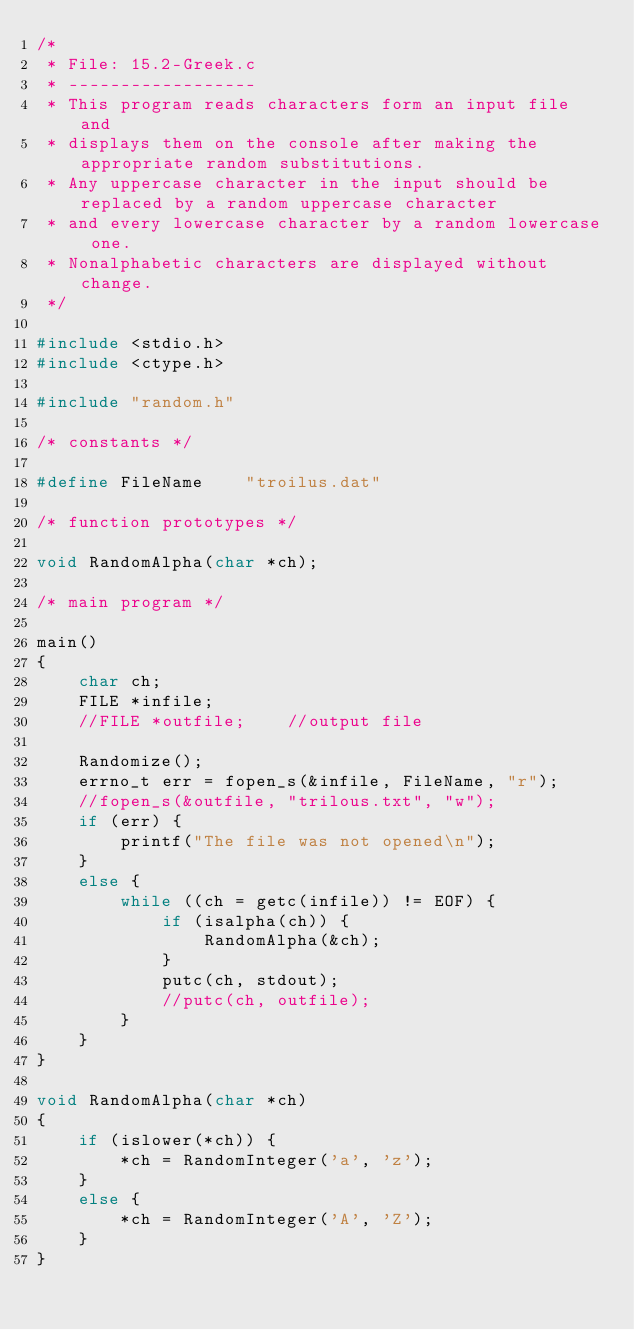<code> <loc_0><loc_0><loc_500><loc_500><_C_>/*
 * File: 15.2-Greek.c
 * ------------------
 * This program reads characters form an input file and
 * displays them on the console after making the appropriate random substitutions.
 * Any uppercase character in the input should be replaced by a random uppercase character
 * and every lowercase character by a random lowercase one.
 * Nonalphabetic characters are displayed without change.
 */

#include <stdio.h>
#include <ctype.h>

#include "random.h"

/* constants */

#define FileName    "troilus.dat"

/* function prototypes */

void RandomAlpha(char *ch);

/* main program */

main()
{
	char ch;
	FILE *infile;
	//FILE *outfile;	//output file

	Randomize();
	errno_t err = fopen_s(&infile, FileName, "r");
	//fopen_s(&outfile, "trilous.txt", "w");
	if (err) {
		printf("The file was not opened\n");
	}
	else {
		while ((ch = getc(infile)) != EOF) {
			if (isalpha(ch)) {
				RandomAlpha(&ch);
			}
			putc(ch, stdout);
			//putc(ch, outfile);
		}
	}
}

void RandomAlpha(char *ch)
{
	if (islower(*ch)) {
		*ch = RandomInteger('a', 'z');
	}
	else {
		*ch = RandomInteger('A', 'Z');
	}
}
</code> 